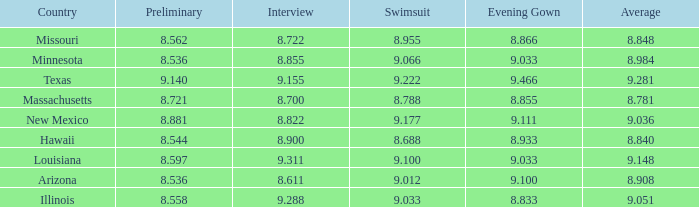What was the swimsuit score for Illinois? 9.033. 